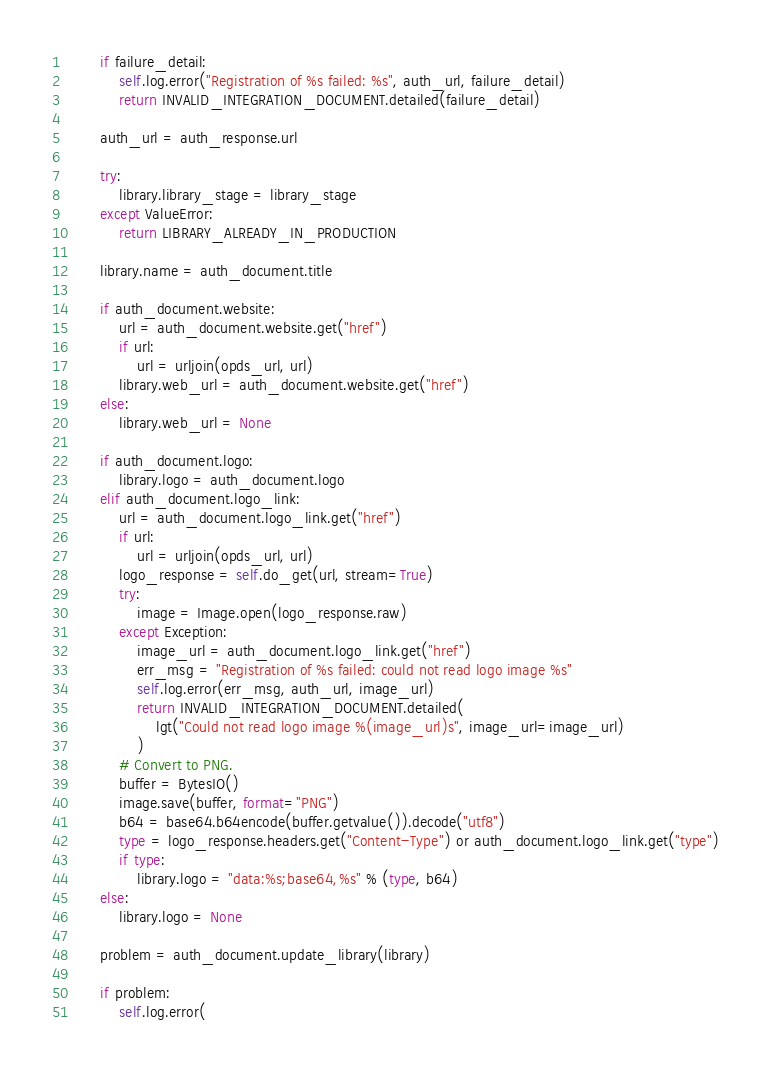Convert code to text. <code><loc_0><loc_0><loc_500><loc_500><_Python_>        if failure_detail:
            self.log.error("Registration of %s failed: %s", auth_url, failure_detail)
            return INVALID_INTEGRATION_DOCUMENT.detailed(failure_detail)

        auth_url = auth_response.url

        try:
            library.library_stage = library_stage
        except ValueError:
            return LIBRARY_ALREADY_IN_PRODUCTION

        library.name = auth_document.title

        if auth_document.website:
            url = auth_document.website.get("href")
            if url:
                url = urljoin(opds_url, url)
            library.web_url = auth_document.website.get("href")
        else:
            library.web_url = None

        if auth_document.logo:
            library.logo = auth_document.logo
        elif auth_document.logo_link:
            url = auth_document.logo_link.get("href")
            if url:
                url = urljoin(opds_url, url)
            logo_response = self.do_get(url, stream=True)
            try:
                image = Image.open(logo_response.raw)
            except Exception:
                image_url = auth_document.logo_link.get("href")
                err_msg = "Registration of %s failed: could not read logo image %s"
                self.log.error(err_msg, auth_url, image_url)
                return INVALID_INTEGRATION_DOCUMENT.detailed(
                    lgt("Could not read logo image %(image_url)s", image_url=image_url)
                )
            # Convert to PNG.
            buffer = BytesIO()
            image.save(buffer, format="PNG")
            b64 = base64.b64encode(buffer.getvalue()).decode("utf8")
            type = logo_response.headers.get("Content-Type") or auth_document.logo_link.get("type")
            if type:
                library.logo = "data:%s;base64,%s" % (type, b64)
        else:
            library.logo = None

        problem = auth_document.update_library(library)

        if problem:
            self.log.error(</code> 